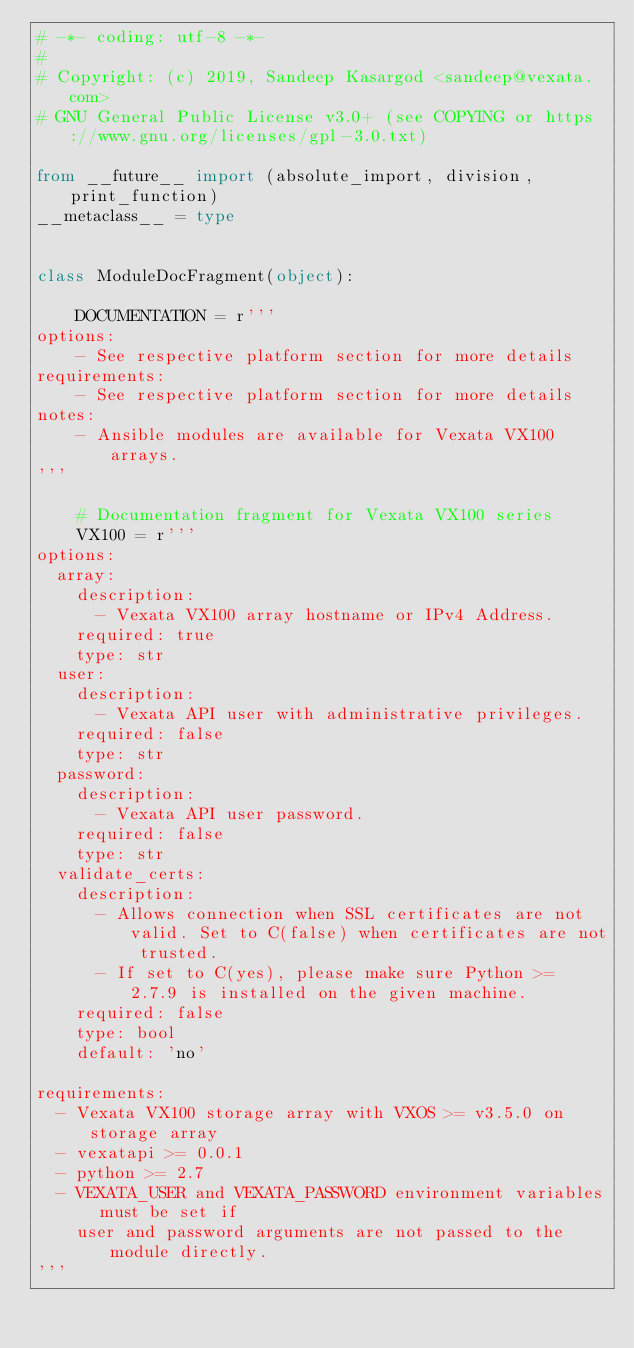Convert code to text. <code><loc_0><loc_0><loc_500><loc_500><_Python_># -*- coding: utf-8 -*-
#
# Copyright: (c) 2019, Sandeep Kasargod <sandeep@vexata.com>
# GNU General Public License v3.0+ (see COPYING or https://www.gnu.org/licenses/gpl-3.0.txt)

from __future__ import (absolute_import, division, print_function)
__metaclass__ = type


class ModuleDocFragment(object):

    DOCUMENTATION = r'''
options:
    - See respective platform section for more details
requirements:
    - See respective platform section for more details
notes:
    - Ansible modules are available for Vexata VX100 arrays.
'''

    # Documentation fragment for Vexata VX100 series
    VX100 = r'''
options:
  array:
    description:
      - Vexata VX100 array hostname or IPv4 Address.
    required: true
    type: str
  user:
    description:
      - Vexata API user with administrative privileges.
    required: false
    type: str
  password:
    description:
      - Vexata API user password.
    required: false
    type: str
  validate_certs:
    description:
      - Allows connection when SSL certificates are not valid. Set to C(false) when certificates are not trusted.
      - If set to C(yes), please make sure Python >= 2.7.9 is installed on the given machine.
    required: false
    type: bool
    default: 'no'

requirements:
  - Vexata VX100 storage array with VXOS >= v3.5.0 on storage array
  - vexatapi >= 0.0.1
  - python >= 2.7
  - VEXATA_USER and VEXATA_PASSWORD environment variables must be set if
    user and password arguments are not passed to the module directly.
'''
</code> 